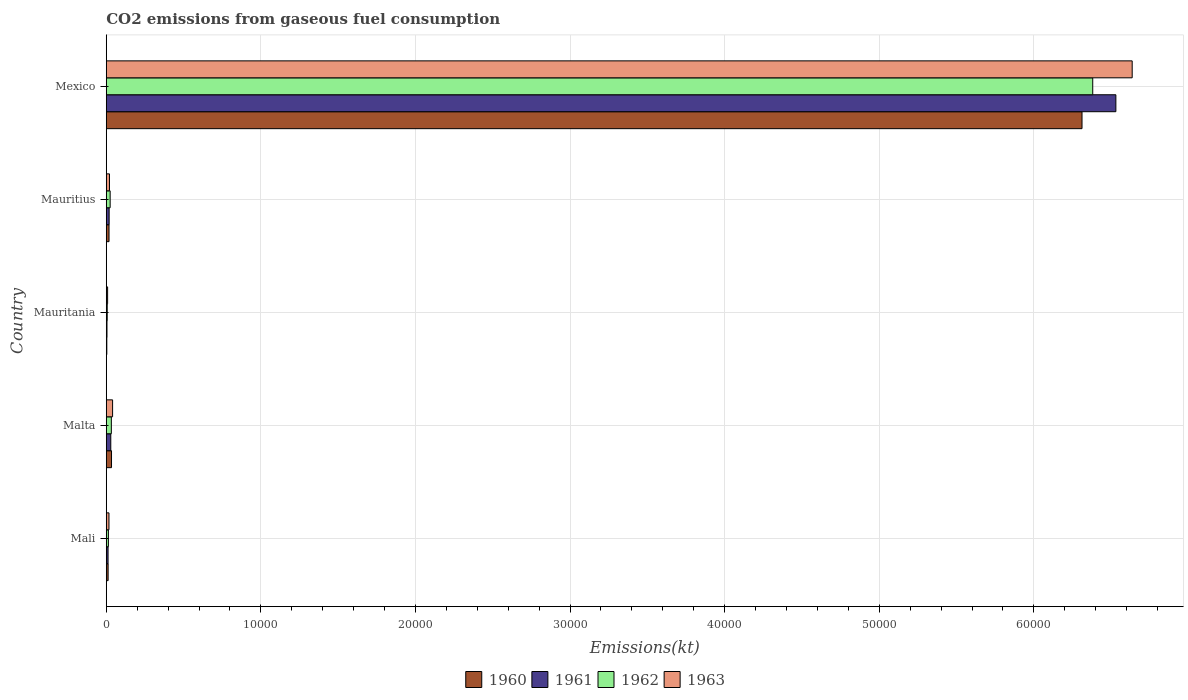How many groups of bars are there?
Your answer should be very brief. 5. What is the amount of CO2 emitted in 1960 in Mauritius?
Your answer should be very brief. 179.68. Across all countries, what is the maximum amount of CO2 emitted in 1961?
Provide a short and direct response. 6.53e+04. Across all countries, what is the minimum amount of CO2 emitted in 1960?
Offer a very short reply. 36.67. In which country was the amount of CO2 emitted in 1961 minimum?
Give a very brief answer. Mauritania. What is the total amount of CO2 emitted in 1961 in the graph?
Provide a succinct answer. 6.60e+04. What is the difference between the amount of CO2 emitted in 1960 in Mauritania and that in Mauritius?
Give a very brief answer. -143.01. What is the difference between the amount of CO2 emitted in 1960 in Mexico and the amount of CO2 emitted in 1961 in Malta?
Make the answer very short. 6.28e+04. What is the average amount of CO2 emitted in 1960 per country?
Your response must be concise. 1.28e+04. What is the difference between the amount of CO2 emitted in 1963 and amount of CO2 emitted in 1962 in Mali?
Provide a succinct answer. 36.67. What is the ratio of the amount of CO2 emitted in 1963 in Malta to that in Mauritius?
Offer a terse response. 1.96. Is the amount of CO2 emitted in 1962 in Mauritius less than that in Mexico?
Your answer should be very brief. Yes. Is the difference between the amount of CO2 emitted in 1963 in Mali and Mexico greater than the difference between the amount of CO2 emitted in 1962 in Mali and Mexico?
Provide a short and direct response. No. What is the difference between the highest and the second highest amount of CO2 emitted in 1962?
Give a very brief answer. 6.35e+04. What is the difference between the highest and the lowest amount of CO2 emitted in 1963?
Provide a short and direct response. 6.63e+04. Is the sum of the amount of CO2 emitted in 1961 in Malta and Mexico greater than the maximum amount of CO2 emitted in 1960 across all countries?
Your answer should be very brief. Yes. Is it the case that in every country, the sum of the amount of CO2 emitted in 1960 and amount of CO2 emitted in 1962 is greater than the sum of amount of CO2 emitted in 1963 and amount of CO2 emitted in 1961?
Keep it short and to the point. No. Is it the case that in every country, the sum of the amount of CO2 emitted in 1963 and amount of CO2 emitted in 1960 is greater than the amount of CO2 emitted in 1961?
Your response must be concise. Yes. How many bars are there?
Make the answer very short. 20. Are all the bars in the graph horizontal?
Provide a succinct answer. Yes. Does the graph contain any zero values?
Your answer should be very brief. No. How many legend labels are there?
Keep it short and to the point. 4. How are the legend labels stacked?
Your answer should be compact. Horizontal. What is the title of the graph?
Offer a very short reply. CO2 emissions from gaseous fuel consumption. What is the label or title of the X-axis?
Give a very brief answer. Emissions(kt). What is the Emissions(kt) of 1960 in Mali?
Offer a very short reply. 121.01. What is the Emissions(kt) in 1961 in Mali?
Keep it short and to the point. 117.34. What is the Emissions(kt) of 1962 in Mali?
Keep it short and to the point. 139.35. What is the Emissions(kt) in 1963 in Mali?
Make the answer very short. 176.02. What is the Emissions(kt) of 1960 in Malta?
Offer a terse response. 341.03. What is the Emissions(kt) of 1961 in Malta?
Ensure brevity in your answer.  293.36. What is the Emissions(kt) of 1962 in Malta?
Keep it short and to the point. 330.03. What is the Emissions(kt) in 1963 in Malta?
Make the answer very short. 410.7. What is the Emissions(kt) of 1960 in Mauritania?
Offer a terse response. 36.67. What is the Emissions(kt) of 1961 in Mauritania?
Provide a succinct answer. 47.67. What is the Emissions(kt) in 1962 in Mauritania?
Your answer should be compact. 62.34. What is the Emissions(kt) in 1963 in Mauritania?
Your response must be concise. 88.01. What is the Emissions(kt) of 1960 in Mauritius?
Your response must be concise. 179.68. What is the Emissions(kt) of 1961 in Mauritius?
Your answer should be very brief. 187.02. What is the Emissions(kt) in 1962 in Mauritius?
Make the answer very short. 253.02. What is the Emissions(kt) of 1963 in Mauritius?
Provide a succinct answer. 209.02. What is the Emissions(kt) of 1960 in Mexico?
Give a very brief answer. 6.31e+04. What is the Emissions(kt) in 1961 in Mexico?
Your answer should be compact. 6.53e+04. What is the Emissions(kt) in 1962 in Mexico?
Provide a succinct answer. 6.38e+04. What is the Emissions(kt) of 1963 in Mexico?
Provide a short and direct response. 6.64e+04. Across all countries, what is the maximum Emissions(kt) in 1960?
Your answer should be compact. 6.31e+04. Across all countries, what is the maximum Emissions(kt) in 1961?
Provide a succinct answer. 6.53e+04. Across all countries, what is the maximum Emissions(kt) of 1962?
Keep it short and to the point. 6.38e+04. Across all countries, what is the maximum Emissions(kt) of 1963?
Keep it short and to the point. 6.64e+04. Across all countries, what is the minimum Emissions(kt) of 1960?
Give a very brief answer. 36.67. Across all countries, what is the minimum Emissions(kt) in 1961?
Keep it short and to the point. 47.67. Across all countries, what is the minimum Emissions(kt) in 1962?
Your answer should be very brief. 62.34. Across all countries, what is the minimum Emissions(kt) in 1963?
Keep it short and to the point. 88.01. What is the total Emissions(kt) in 1960 in the graph?
Provide a short and direct response. 6.38e+04. What is the total Emissions(kt) of 1961 in the graph?
Your answer should be very brief. 6.60e+04. What is the total Emissions(kt) in 1962 in the graph?
Offer a very short reply. 6.46e+04. What is the total Emissions(kt) of 1963 in the graph?
Provide a short and direct response. 6.72e+04. What is the difference between the Emissions(kt) of 1960 in Mali and that in Malta?
Offer a very short reply. -220.02. What is the difference between the Emissions(kt) in 1961 in Mali and that in Malta?
Your answer should be very brief. -176.02. What is the difference between the Emissions(kt) of 1962 in Mali and that in Malta?
Offer a terse response. -190.68. What is the difference between the Emissions(kt) in 1963 in Mali and that in Malta?
Make the answer very short. -234.69. What is the difference between the Emissions(kt) in 1960 in Mali and that in Mauritania?
Your response must be concise. 84.34. What is the difference between the Emissions(kt) of 1961 in Mali and that in Mauritania?
Offer a terse response. 69.67. What is the difference between the Emissions(kt) of 1962 in Mali and that in Mauritania?
Ensure brevity in your answer.  77.01. What is the difference between the Emissions(kt) in 1963 in Mali and that in Mauritania?
Offer a very short reply. 88.01. What is the difference between the Emissions(kt) of 1960 in Mali and that in Mauritius?
Make the answer very short. -58.67. What is the difference between the Emissions(kt) of 1961 in Mali and that in Mauritius?
Give a very brief answer. -69.67. What is the difference between the Emissions(kt) in 1962 in Mali and that in Mauritius?
Keep it short and to the point. -113.68. What is the difference between the Emissions(kt) of 1963 in Mali and that in Mauritius?
Your answer should be very brief. -33. What is the difference between the Emissions(kt) in 1960 in Mali and that in Mexico?
Your answer should be compact. -6.30e+04. What is the difference between the Emissions(kt) in 1961 in Mali and that in Mexico?
Your response must be concise. -6.52e+04. What is the difference between the Emissions(kt) of 1962 in Mali and that in Mexico?
Give a very brief answer. -6.37e+04. What is the difference between the Emissions(kt) of 1963 in Mali and that in Mexico?
Your response must be concise. -6.62e+04. What is the difference between the Emissions(kt) in 1960 in Malta and that in Mauritania?
Give a very brief answer. 304.36. What is the difference between the Emissions(kt) of 1961 in Malta and that in Mauritania?
Make the answer very short. 245.69. What is the difference between the Emissions(kt) of 1962 in Malta and that in Mauritania?
Provide a succinct answer. 267.69. What is the difference between the Emissions(kt) of 1963 in Malta and that in Mauritania?
Provide a short and direct response. 322.7. What is the difference between the Emissions(kt) in 1960 in Malta and that in Mauritius?
Provide a succinct answer. 161.35. What is the difference between the Emissions(kt) in 1961 in Malta and that in Mauritius?
Provide a succinct answer. 106.34. What is the difference between the Emissions(kt) in 1962 in Malta and that in Mauritius?
Your response must be concise. 77.01. What is the difference between the Emissions(kt) in 1963 in Malta and that in Mauritius?
Your response must be concise. 201.69. What is the difference between the Emissions(kt) in 1960 in Malta and that in Mexico?
Your answer should be compact. -6.28e+04. What is the difference between the Emissions(kt) of 1961 in Malta and that in Mexico?
Your response must be concise. -6.50e+04. What is the difference between the Emissions(kt) in 1962 in Malta and that in Mexico?
Provide a short and direct response. -6.35e+04. What is the difference between the Emissions(kt) of 1963 in Malta and that in Mexico?
Give a very brief answer. -6.60e+04. What is the difference between the Emissions(kt) in 1960 in Mauritania and that in Mauritius?
Offer a terse response. -143.01. What is the difference between the Emissions(kt) of 1961 in Mauritania and that in Mauritius?
Ensure brevity in your answer.  -139.35. What is the difference between the Emissions(kt) in 1962 in Mauritania and that in Mauritius?
Give a very brief answer. -190.68. What is the difference between the Emissions(kt) in 1963 in Mauritania and that in Mauritius?
Provide a succinct answer. -121.01. What is the difference between the Emissions(kt) in 1960 in Mauritania and that in Mexico?
Provide a succinct answer. -6.31e+04. What is the difference between the Emissions(kt) of 1961 in Mauritania and that in Mexico?
Make the answer very short. -6.53e+04. What is the difference between the Emissions(kt) in 1962 in Mauritania and that in Mexico?
Provide a short and direct response. -6.37e+04. What is the difference between the Emissions(kt) in 1963 in Mauritania and that in Mexico?
Offer a very short reply. -6.63e+04. What is the difference between the Emissions(kt) in 1960 in Mauritius and that in Mexico?
Your answer should be compact. -6.29e+04. What is the difference between the Emissions(kt) in 1961 in Mauritius and that in Mexico?
Make the answer very short. -6.51e+04. What is the difference between the Emissions(kt) of 1962 in Mauritius and that in Mexico?
Ensure brevity in your answer.  -6.36e+04. What is the difference between the Emissions(kt) in 1963 in Mauritius and that in Mexico?
Your response must be concise. -6.62e+04. What is the difference between the Emissions(kt) in 1960 in Mali and the Emissions(kt) in 1961 in Malta?
Keep it short and to the point. -172.35. What is the difference between the Emissions(kt) in 1960 in Mali and the Emissions(kt) in 1962 in Malta?
Offer a very short reply. -209.02. What is the difference between the Emissions(kt) in 1960 in Mali and the Emissions(kt) in 1963 in Malta?
Provide a succinct answer. -289.69. What is the difference between the Emissions(kt) of 1961 in Mali and the Emissions(kt) of 1962 in Malta?
Give a very brief answer. -212.69. What is the difference between the Emissions(kt) of 1961 in Mali and the Emissions(kt) of 1963 in Malta?
Offer a very short reply. -293.36. What is the difference between the Emissions(kt) of 1962 in Mali and the Emissions(kt) of 1963 in Malta?
Provide a succinct answer. -271.36. What is the difference between the Emissions(kt) of 1960 in Mali and the Emissions(kt) of 1961 in Mauritania?
Your response must be concise. 73.34. What is the difference between the Emissions(kt) of 1960 in Mali and the Emissions(kt) of 1962 in Mauritania?
Provide a short and direct response. 58.67. What is the difference between the Emissions(kt) in 1960 in Mali and the Emissions(kt) in 1963 in Mauritania?
Ensure brevity in your answer.  33. What is the difference between the Emissions(kt) in 1961 in Mali and the Emissions(kt) in 1962 in Mauritania?
Provide a succinct answer. 55.01. What is the difference between the Emissions(kt) of 1961 in Mali and the Emissions(kt) of 1963 in Mauritania?
Provide a succinct answer. 29.34. What is the difference between the Emissions(kt) of 1962 in Mali and the Emissions(kt) of 1963 in Mauritania?
Keep it short and to the point. 51.34. What is the difference between the Emissions(kt) in 1960 in Mali and the Emissions(kt) in 1961 in Mauritius?
Your answer should be compact. -66.01. What is the difference between the Emissions(kt) in 1960 in Mali and the Emissions(kt) in 1962 in Mauritius?
Make the answer very short. -132.01. What is the difference between the Emissions(kt) of 1960 in Mali and the Emissions(kt) of 1963 in Mauritius?
Ensure brevity in your answer.  -88.01. What is the difference between the Emissions(kt) in 1961 in Mali and the Emissions(kt) in 1962 in Mauritius?
Keep it short and to the point. -135.68. What is the difference between the Emissions(kt) in 1961 in Mali and the Emissions(kt) in 1963 in Mauritius?
Give a very brief answer. -91.67. What is the difference between the Emissions(kt) of 1962 in Mali and the Emissions(kt) of 1963 in Mauritius?
Make the answer very short. -69.67. What is the difference between the Emissions(kt) of 1960 in Mali and the Emissions(kt) of 1961 in Mexico?
Ensure brevity in your answer.  -6.52e+04. What is the difference between the Emissions(kt) in 1960 in Mali and the Emissions(kt) in 1962 in Mexico?
Your response must be concise. -6.37e+04. What is the difference between the Emissions(kt) in 1960 in Mali and the Emissions(kt) in 1963 in Mexico?
Your response must be concise. -6.62e+04. What is the difference between the Emissions(kt) of 1961 in Mali and the Emissions(kt) of 1962 in Mexico?
Provide a succinct answer. -6.37e+04. What is the difference between the Emissions(kt) of 1961 in Mali and the Emissions(kt) of 1963 in Mexico?
Provide a short and direct response. -6.62e+04. What is the difference between the Emissions(kt) of 1962 in Mali and the Emissions(kt) of 1963 in Mexico?
Offer a very short reply. -6.62e+04. What is the difference between the Emissions(kt) of 1960 in Malta and the Emissions(kt) of 1961 in Mauritania?
Your answer should be compact. 293.36. What is the difference between the Emissions(kt) of 1960 in Malta and the Emissions(kt) of 1962 in Mauritania?
Your response must be concise. 278.69. What is the difference between the Emissions(kt) in 1960 in Malta and the Emissions(kt) in 1963 in Mauritania?
Your answer should be very brief. 253.02. What is the difference between the Emissions(kt) in 1961 in Malta and the Emissions(kt) in 1962 in Mauritania?
Your answer should be compact. 231.02. What is the difference between the Emissions(kt) in 1961 in Malta and the Emissions(kt) in 1963 in Mauritania?
Your answer should be very brief. 205.35. What is the difference between the Emissions(kt) in 1962 in Malta and the Emissions(kt) in 1963 in Mauritania?
Provide a succinct answer. 242.02. What is the difference between the Emissions(kt) of 1960 in Malta and the Emissions(kt) of 1961 in Mauritius?
Make the answer very short. 154.01. What is the difference between the Emissions(kt) of 1960 in Malta and the Emissions(kt) of 1962 in Mauritius?
Provide a succinct answer. 88.01. What is the difference between the Emissions(kt) of 1960 in Malta and the Emissions(kt) of 1963 in Mauritius?
Provide a short and direct response. 132.01. What is the difference between the Emissions(kt) in 1961 in Malta and the Emissions(kt) in 1962 in Mauritius?
Make the answer very short. 40.34. What is the difference between the Emissions(kt) in 1961 in Malta and the Emissions(kt) in 1963 in Mauritius?
Provide a short and direct response. 84.34. What is the difference between the Emissions(kt) of 1962 in Malta and the Emissions(kt) of 1963 in Mauritius?
Make the answer very short. 121.01. What is the difference between the Emissions(kt) of 1960 in Malta and the Emissions(kt) of 1961 in Mexico?
Keep it short and to the point. -6.50e+04. What is the difference between the Emissions(kt) in 1960 in Malta and the Emissions(kt) in 1962 in Mexico?
Provide a short and direct response. -6.35e+04. What is the difference between the Emissions(kt) in 1960 in Malta and the Emissions(kt) in 1963 in Mexico?
Offer a terse response. -6.60e+04. What is the difference between the Emissions(kt) in 1961 in Malta and the Emissions(kt) in 1962 in Mexico?
Your response must be concise. -6.35e+04. What is the difference between the Emissions(kt) in 1961 in Malta and the Emissions(kt) in 1963 in Mexico?
Offer a very short reply. -6.61e+04. What is the difference between the Emissions(kt) of 1962 in Malta and the Emissions(kt) of 1963 in Mexico?
Your answer should be very brief. -6.60e+04. What is the difference between the Emissions(kt) of 1960 in Mauritania and the Emissions(kt) of 1961 in Mauritius?
Offer a terse response. -150.35. What is the difference between the Emissions(kt) in 1960 in Mauritania and the Emissions(kt) in 1962 in Mauritius?
Your response must be concise. -216.35. What is the difference between the Emissions(kt) in 1960 in Mauritania and the Emissions(kt) in 1963 in Mauritius?
Offer a terse response. -172.35. What is the difference between the Emissions(kt) in 1961 in Mauritania and the Emissions(kt) in 1962 in Mauritius?
Provide a short and direct response. -205.35. What is the difference between the Emissions(kt) of 1961 in Mauritania and the Emissions(kt) of 1963 in Mauritius?
Offer a terse response. -161.35. What is the difference between the Emissions(kt) in 1962 in Mauritania and the Emissions(kt) in 1963 in Mauritius?
Keep it short and to the point. -146.68. What is the difference between the Emissions(kt) of 1960 in Mauritania and the Emissions(kt) of 1961 in Mexico?
Provide a succinct answer. -6.53e+04. What is the difference between the Emissions(kt) in 1960 in Mauritania and the Emissions(kt) in 1962 in Mexico?
Your answer should be very brief. -6.38e+04. What is the difference between the Emissions(kt) of 1960 in Mauritania and the Emissions(kt) of 1963 in Mexico?
Your answer should be compact. -6.63e+04. What is the difference between the Emissions(kt) of 1961 in Mauritania and the Emissions(kt) of 1962 in Mexico?
Offer a terse response. -6.38e+04. What is the difference between the Emissions(kt) of 1961 in Mauritania and the Emissions(kt) of 1963 in Mexico?
Offer a very short reply. -6.63e+04. What is the difference between the Emissions(kt) of 1962 in Mauritania and the Emissions(kt) of 1963 in Mexico?
Give a very brief answer. -6.63e+04. What is the difference between the Emissions(kt) in 1960 in Mauritius and the Emissions(kt) in 1961 in Mexico?
Make the answer very short. -6.51e+04. What is the difference between the Emissions(kt) of 1960 in Mauritius and the Emissions(kt) of 1962 in Mexico?
Your answer should be compact. -6.36e+04. What is the difference between the Emissions(kt) of 1960 in Mauritius and the Emissions(kt) of 1963 in Mexico?
Keep it short and to the point. -6.62e+04. What is the difference between the Emissions(kt) of 1961 in Mauritius and the Emissions(kt) of 1962 in Mexico?
Keep it short and to the point. -6.36e+04. What is the difference between the Emissions(kt) of 1961 in Mauritius and the Emissions(kt) of 1963 in Mexico?
Your response must be concise. -6.62e+04. What is the difference between the Emissions(kt) of 1962 in Mauritius and the Emissions(kt) of 1963 in Mexico?
Your answer should be very brief. -6.61e+04. What is the average Emissions(kt) in 1960 per country?
Offer a terse response. 1.28e+04. What is the average Emissions(kt) of 1961 per country?
Your response must be concise. 1.32e+04. What is the average Emissions(kt) in 1962 per country?
Keep it short and to the point. 1.29e+04. What is the average Emissions(kt) of 1963 per country?
Offer a very short reply. 1.34e+04. What is the difference between the Emissions(kt) in 1960 and Emissions(kt) in 1961 in Mali?
Offer a terse response. 3.67. What is the difference between the Emissions(kt) in 1960 and Emissions(kt) in 1962 in Mali?
Your answer should be very brief. -18.34. What is the difference between the Emissions(kt) in 1960 and Emissions(kt) in 1963 in Mali?
Your response must be concise. -55.01. What is the difference between the Emissions(kt) of 1961 and Emissions(kt) of 1962 in Mali?
Provide a short and direct response. -22. What is the difference between the Emissions(kt) of 1961 and Emissions(kt) of 1963 in Mali?
Provide a short and direct response. -58.67. What is the difference between the Emissions(kt) of 1962 and Emissions(kt) of 1963 in Mali?
Make the answer very short. -36.67. What is the difference between the Emissions(kt) in 1960 and Emissions(kt) in 1961 in Malta?
Your response must be concise. 47.67. What is the difference between the Emissions(kt) of 1960 and Emissions(kt) of 1962 in Malta?
Offer a very short reply. 11. What is the difference between the Emissions(kt) of 1960 and Emissions(kt) of 1963 in Malta?
Your answer should be very brief. -69.67. What is the difference between the Emissions(kt) in 1961 and Emissions(kt) in 1962 in Malta?
Offer a terse response. -36.67. What is the difference between the Emissions(kt) in 1961 and Emissions(kt) in 1963 in Malta?
Make the answer very short. -117.34. What is the difference between the Emissions(kt) of 1962 and Emissions(kt) of 1963 in Malta?
Your answer should be compact. -80.67. What is the difference between the Emissions(kt) in 1960 and Emissions(kt) in 1961 in Mauritania?
Give a very brief answer. -11. What is the difference between the Emissions(kt) of 1960 and Emissions(kt) of 1962 in Mauritania?
Ensure brevity in your answer.  -25.67. What is the difference between the Emissions(kt) in 1960 and Emissions(kt) in 1963 in Mauritania?
Offer a terse response. -51.34. What is the difference between the Emissions(kt) in 1961 and Emissions(kt) in 1962 in Mauritania?
Your answer should be very brief. -14.67. What is the difference between the Emissions(kt) of 1961 and Emissions(kt) of 1963 in Mauritania?
Your response must be concise. -40.34. What is the difference between the Emissions(kt) of 1962 and Emissions(kt) of 1963 in Mauritania?
Your response must be concise. -25.67. What is the difference between the Emissions(kt) of 1960 and Emissions(kt) of 1961 in Mauritius?
Provide a short and direct response. -7.33. What is the difference between the Emissions(kt) of 1960 and Emissions(kt) of 1962 in Mauritius?
Offer a very short reply. -73.34. What is the difference between the Emissions(kt) of 1960 and Emissions(kt) of 1963 in Mauritius?
Give a very brief answer. -29.34. What is the difference between the Emissions(kt) in 1961 and Emissions(kt) in 1962 in Mauritius?
Provide a short and direct response. -66.01. What is the difference between the Emissions(kt) of 1961 and Emissions(kt) of 1963 in Mauritius?
Provide a succinct answer. -22. What is the difference between the Emissions(kt) of 1962 and Emissions(kt) of 1963 in Mauritius?
Keep it short and to the point. 44. What is the difference between the Emissions(kt) of 1960 and Emissions(kt) of 1961 in Mexico?
Provide a succinct answer. -2189.2. What is the difference between the Emissions(kt) of 1960 and Emissions(kt) of 1962 in Mexico?
Ensure brevity in your answer.  -693.06. What is the difference between the Emissions(kt) in 1960 and Emissions(kt) in 1963 in Mexico?
Your answer should be very brief. -3245.3. What is the difference between the Emissions(kt) of 1961 and Emissions(kt) of 1962 in Mexico?
Offer a very short reply. 1496.14. What is the difference between the Emissions(kt) of 1961 and Emissions(kt) of 1963 in Mexico?
Keep it short and to the point. -1056.1. What is the difference between the Emissions(kt) of 1962 and Emissions(kt) of 1963 in Mexico?
Your answer should be very brief. -2552.23. What is the ratio of the Emissions(kt) of 1960 in Mali to that in Malta?
Ensure brevity in your answer.  0.35. What is the ratio of the Emissions(kt) of 1961 in Mali to that in Malta?
Offer a very short reply. 0.4. What is the ratio of the Emissions(kt) in 1962 in Mali to that in Malta?
Your answer should be compact. 0.42. What is the ratio of the Emissions(kt) of 1963 in Mali to that in Malta?
Ensure brevity in your answer.  0.43. What is the ratio of the Emissions(kt) in 1961 in Mali to that in Mauritania?
Your answer should be compact. 2.46. What is the ratio of the Emissions(kt) of 1962 in Mali to that in Mauritania?
Ensure brevity in your answer.  2.24. What is the ratio of the Emissions(kt) of 1963 in Mali to that in Mauritania?
Offer a very short reply. 2. What is the ratio of the Emissions(kt) in 1960 in Mali to that in Mauritius?
Provide a short and direct response. 0.67. What is the ratio of the Emissions(kt) in 1961 in Mali to that in Mauritius?
Offer a very short reply. 0.63. What is the ratio of the Emissions(kt) in 1962 in Mali to that in Mauritius?
Your answer should be compact. 0.55. What is the ratio of the Emissions(kt) in 1963 in Mali to that in Mauritius?
Ensure brevity in your answer.  0.84. What is the ratio of the Emissions(kt) of 1960 in Mali to that in Mexico?
Provide a short and direct response. 0. What is the ratio of the Emissions(kt) of 1961 in Mali to that in Mexico?
Provide a short and direct response. 0. What is the ratio of the Emissions(kt) in 1962 in Mali to that in Mexico?
Your answer should be compact. 0. What is the ratio of the Emissions(kt) of 1963 in Mali to that in Mexico?
Ensure brevity in your answer.  0. What is the ratio of the Emissions(kt) in 1961 in Malta to that in Mauritania?
Provide a succinct answer. 6.15. What is the ratio of the Emissions(kt) of 1962 in Malta to that in Mauritania?
Ensure brevity in your answer.  5.29. What is the ratio of the Emissions(kt) in 1963 in Malta to that in Mauritania?
Your answer should be very brief. 4.67. What is the ratio of the Emissions(kt) in 1960 in Malta to that in Mauritius?
Keep it short and to the point. 1.9. What is the ratio of the Emissions(kt) of 1961 in Malta to that in Mauritius?
Your answer should be very brief. 1.57. What is the ratio of the Emissions(kt) of 1962 in Malta to that in Mauritius?
Offer a very short reply. 1.3. What is the ratio of the Emissions(kt) in 1963 in Malta to that in Mauritius?
Keep it short and to the point. 1.96. What is the ratio of the Emissions(kt) of 1960 in Malta to that in Mexico?
Provide a succinct answer. 0.01. What is the ratio of the Emissions(kt) in 1961 in Malta to that in Mexico?
Provide a short and direct response. 0. What is the ratio of the Emissions(kt) in 1962 in Malta to that in Mexico?
Offer a terse response. 0.01. What is the ratio of the Emissions(kt) in 1963 in Malta to that in Mexico?
Provide a succinct answer. 0.01. What is the ratio of the Emissions(kt) in 1960 in Mauritania to that in Mauritius?
Keep it short and to the point. 0.2. What is the ratio of the Emissions(kt) of 1961 in Mauritania to that in Mauritius?
Your answer should be compact. 0.25. What is the ratio of the Emissions(kt) of 1962 in Mauritania to that in Mauritius?
Provide a short and direct response. 0.25. What is the ratio of the Emissions(kt) in 1963 in Mauritania to that in Mauritius?
Offer a very short reply. 0.42. What is the ratio of the Emissions(kt) of 1960 in Mauritania to that in Mexico?
Provide a short and direct response. 0. What is the ratio of the Emissions(kt) of 1961 in Mauritania to that in Mexico?
Keep it short and to the point. 0. What is the ratio of the Emissions(kt) of 1963 in Mauritania to that in Mexico?
Keep it short and to the point. 0. What is the ratio of the Emissions(kt) of 1960 in Mauritius to that in Mexico?
Provide a succinct answer. 0. What is the ratio of the Emissions(kt) of 1961 in Mauritius to that in Mexico?
Offer a terse response. 0. What is the ratio of the Emissions(kt) in 1962 in Mauritius to that in Mexico?
Ensure brevity in your answer.  0. What is the ratio of the Emissions(kt) in 1963 in Mauritius to that in Mexico?
Your answer should be very brief. 0. What is the difference between the highest and the second highest Emissions(kt) in 1960?
Your answer should be compact. 6.28e+04. What is the difference between the highest and the second highest Emissions(kt) in 1961?
Offer a very short reply. 6.50e+04. What is the difference between the highest and the second highest Emissions(kt) in 1962?
Offer a very short reply. 6.35e+04. What is the difference between the highest and the second highest Emissions(kt) of 1963?
Make the answer very short. 6.60e+04. What is the difference between the highest and the lowest Emissions(kt) in 1960?
Make the answer very short. 6.31e+04. What is the difference between the highest and the lowest Emissions(kt) in 1961?
Give a very brief answer. 6.53e+04. What is the difference between the highest and the lowest Emissions(kt) of 1962?
Your answer should be compact. 6.37e+04. What is the difference between the highest and the lowest Emissions(kt) in 1963?
Ensure brevity in your answer.  6.63e+04. 